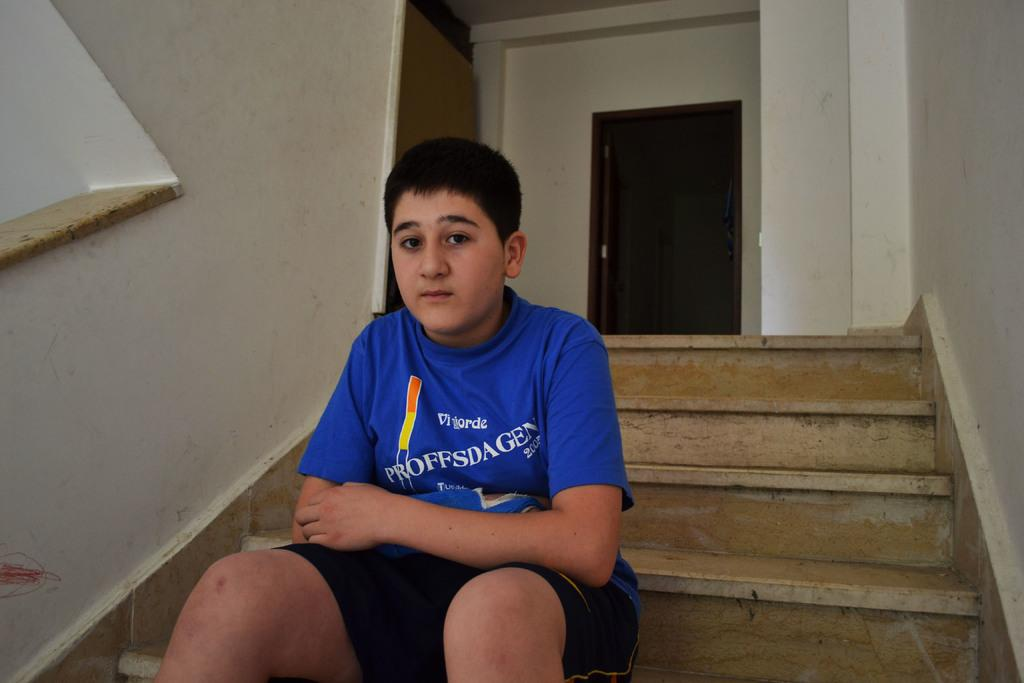<image>
Render a clear and concise summary of the photo. A boy sitting on steps wears a blue shirt with words that say, "Vigiorde Proffsdagen 2005". 